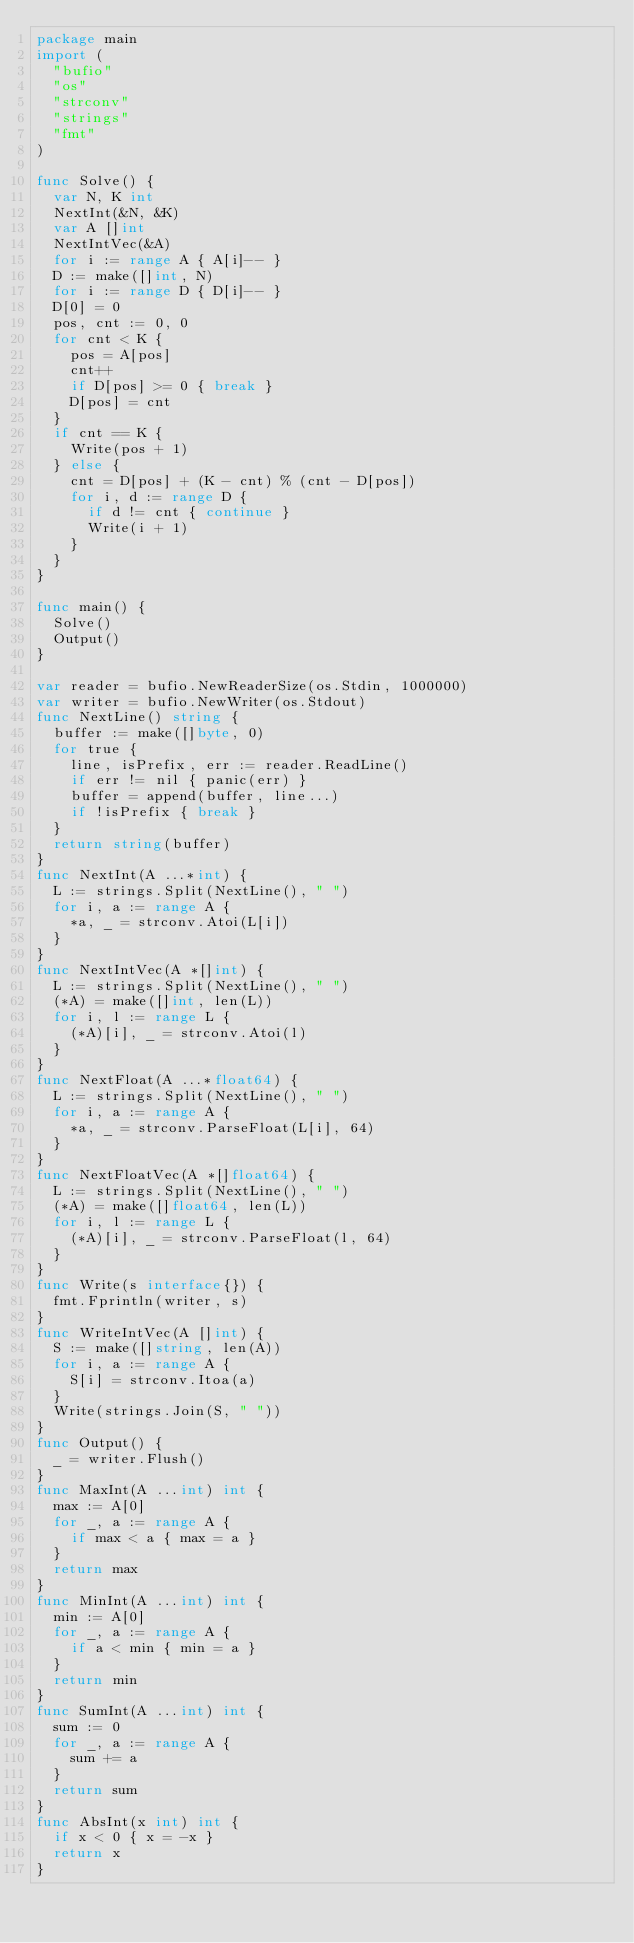<code> <loc_0><loc_0><loc_500><loc_500><_Go_>package main
import (
  "bufio"
  "os"
  "strconv"
  "strings"
  "fmt"
)

func Solve() {
  var N, K int
  NextInt(&N, &K)
  var A []int
  NextIntVec(&A)
  for i := range A { A[i]-- }
  D := make([]int, N)
  for i := range D { D[i]-- }
  D[0] = 0
  pos, cnt := 0, 0
  for cnt < K {
    pos = A[pos]
    cnt++
    if D[pos] >= 0 { break }
    D[pos] = cnt
  }
  if cnt == K {
    Write(pos + 1)
  } else {
    cnt = D[pos] + (K - cnt) % (cnt - D[pos])
    for i, d := range D {
      if d != cnt { continue }
      Write(i + 1)
    }
  }
}

func main() {
  Solve()
  Output()
}

var reader = bufio.NewReaderSize(os.Stdin, 1000000)
var writer = bufio.NewWriter(os.Stdout)
func NextLine() string {
  buffer := make([]byte, 0)
  for true {
    line, isPrefix, err := reader.ReadLine()
    if err != nil { panic(err) }
    buffer = append(buffer, line...)
    if !isPrefix { break }
  }
  return string(buffer)
}
func NextInt(A ...*int) {
  L := strings.Split(NextLine(), " ")
  for i, a := range A {
    *a, _ = strconv.Atoi(L[i])
  }
}
func NextIntVec(A *[]int) {
  L := strings.Split(NextLine(), " ")
  (*A) = make([]int, len(L))
  for i, l := range L {
    (*A)[i], _ = strconv.Atoi(l)
  }
}
func NextFloat(A ...*float64) {
  L := strings.Split(NextLine(), " ")
  for i, a := range A {
    *a, _ = strconv.ParseFloat(L[i], 64)
  }
}
func NextFloatVec(A *[]float64) {
  L := strings.Split(NextLine(), " ")
  (*A) = make([]float64, len(L))
  for i, l := range L {
    (*A)[i], _ = strconv.ParseFloat(l, 64)
  }
}
func Write(s interface{}) {
  fmt.Fprintln(writer, s)
}
func WriteIntVec(A []int) {
  S := make([]string, len(A))
  for i, a := range A {
    S[i] = strconv.Itoa(a)
  }
  Write(strings.Join(S, " "))
}
func Output() {
  _ = writer.Flush()
}
func MaxInt(A ...int) int {
  max := A[0]
  for _, a := range A {
    if max < a { max = a }
  }
  return max
}
func MinInt(A ...int) int {
  min := A[0]
  for _, a := range A {
    if a < min { min = a }
  }
  return min
}
func SumInt(A ...int) int {
  sum := 0
  for _, a := range A {
    sum += a
  }
  return sum
}
func AbsInt(x int) int {
  if x < 0 { x = -x }
  return x
}</code> 